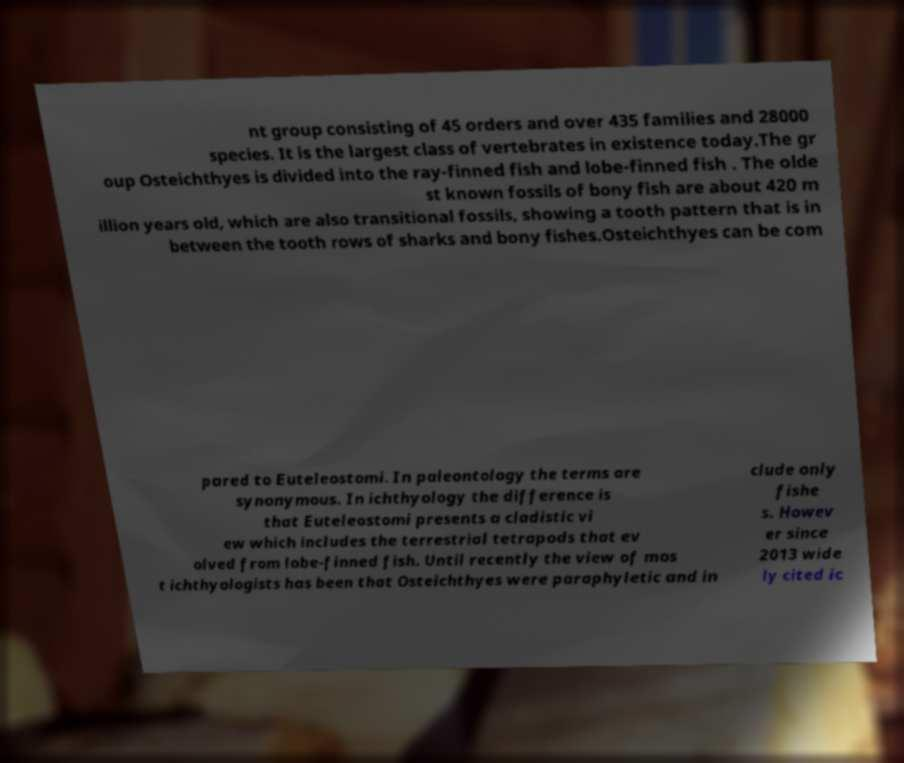Please read and relay the text visible in this image. What does it say? nt group consisting of 45 orders and over 435 families and 28000 species. It is the largest class of vertebrates in existence today.The gr oup Osteichthyes is divided into the ray-finned fish and lobe-finned fish . The olde st known fossils of bony fish are about 420 m illion years old, which are also transitional fossils, showing a tooth pattern that is in between the tooth rows of sharks and bony fishes.Osteichthyes can be com pared to Euteleostomi. In paleontology the terms are synonymous. In ichthyology the difference is that Euteleostomi presents a cladistic vi ew which includes the terrestrial tetrapods that ev olved from lobe-finned fish. Until recently the view of mos t ichthyologists has been that Osteichthyes were paraphyletic and in clude only fishe s. Howev er since 2013 wide ly cited ic 